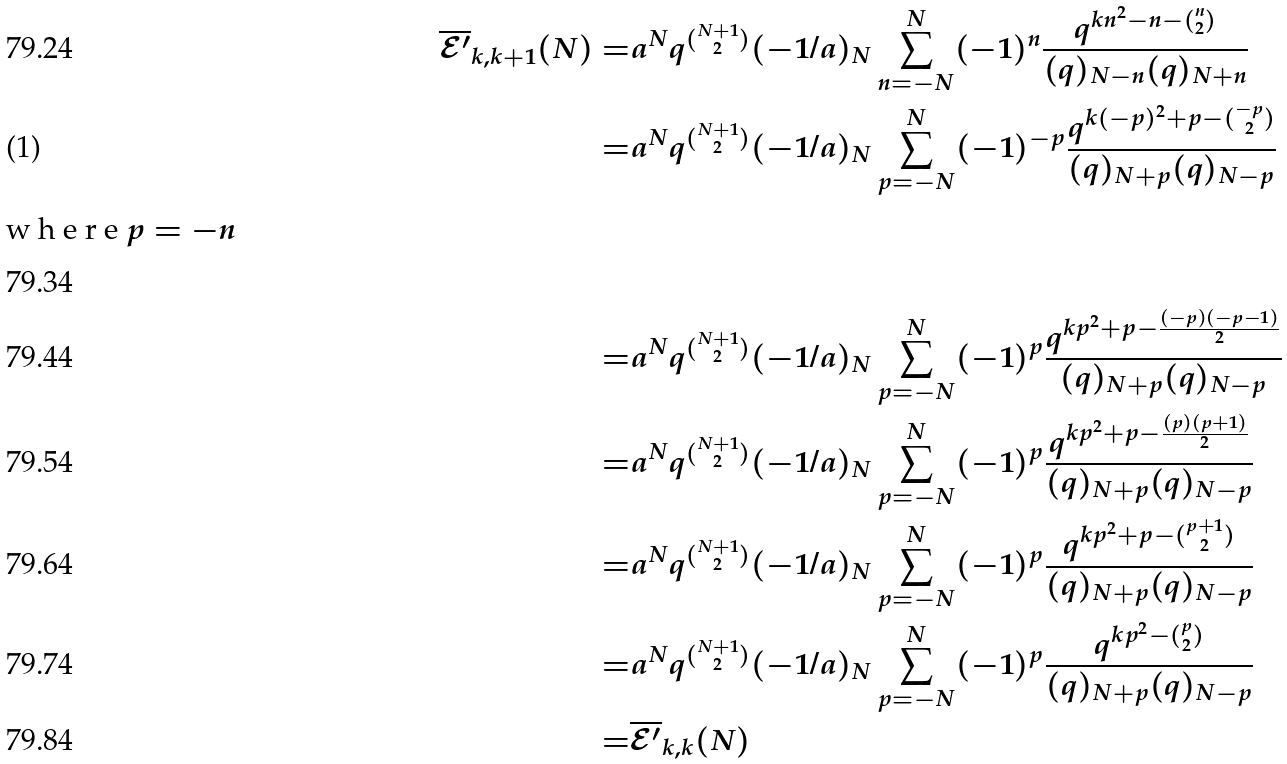Convert formula to latex. <formula><loc_0><loc_0><loc_500><loc_500>\overline { \mathcal { E } ^ { \prime } } _ { k , k + 1 } ( N ) = & a ^ { N } q ^ { \binom { N + 1 } { 2 } } ( - 1 / a ) _ { N } \sum _ { n = - N } ^ { N } ( - 1 ) ^ { n } \frac { q ^ { k n ^ { 2 } - n - { \binom { n } { 2 } } } } { ( q ) _ { N - n } ( q ) _ { N + n } } \\ = & a ^ { N } q ^ { \binom { N + 1 } { 2 } } ( - 1 / a ) _ { N } \sum _ { p = - N } ^ { N } ( - 1 ) ^ { - p } \frac { q ^ { k ( - p ) ^ { 2 } + p - { \binom { - p } { 2 } } } } { ( q ) _ { N + p } ( q ) _ { N - p } } \intertext { w h e r e $ p = - n $ } \\ = & a ^ { N } q ^ { \binom { N + 1 } { 2 } } ( - 1 / a ) _ { N } \sum _ { p = - N } ^ { N } ( - 1 ) ^ { p } \frac { q ^ { k p ^ { 2 } + p - \frac { ( - p ) ( - p - 1 ) } { 2 } } } { ( q ) _ { N + p } ( q ) _ { N - p } } \\ = & a ^ { N } q ^ { \binom { N + 1 } { 2 } } ( - 1 / a ) _ { N } \sum _ { p = - N } ^ { N } ( - 1 ) ^ { p } \frac { q ^ { k p ^ { 2 } + p - \frac { ( p ) ( p + 1 ) } { 2 } } } { ( q ) _ { N + p } ( q ) _ { N - p } } \\ = & a ^ { N } q ^ { \binom { N + 1 } { 2 } } ( - 1 / a ) _ { N } \sum _ { p = - N } ^ { N } ( - 1 ) ^ { p } \frac { q ^ { k p ^ { 2 } + p - \binom { p + 1 } { 2 } } } { ( q ) _ { N + p } ( q ) _ { N - p } } \\ = & a ^ { N } q ^ { \binom { N + 1 } { 2 } } ( - 1 / a ) _ { N } \sum _ { p = - N } ^ { N } ( - 1 ) ^ { p } \frac { q ^ { k p ^ { 2 } - \binom { p } { 2 } } } { ( q ) _ { N + p } ( q ) _ { N - p } } \\ = & \overline { \mathcal { E } ^ { \prime } } _ { k , k } ( N )</formula> 